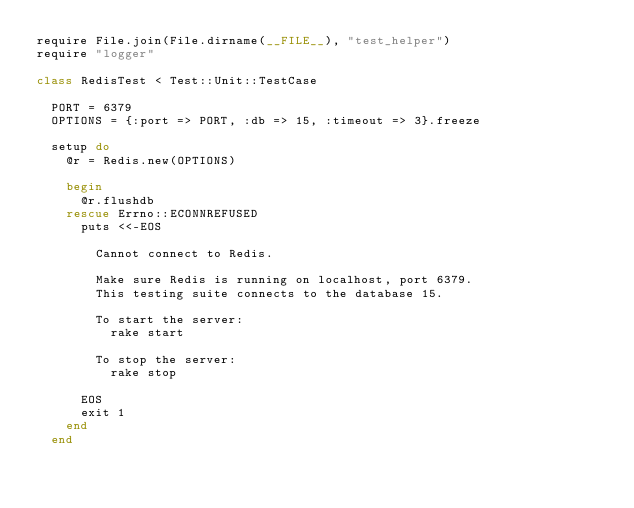<code> <loc_0><loc_0><loc_500><loc_500><_Ruby_>require File.join(File.dirname(__FILE__), "test_helper")
require "logger"

class RedisTest < Test::Unit::TestCase

  PORT = 6379
  OPTIONS = {:port => PORT, :db => 15, :timeout => 3}.freeze

  setup do
    @r = Redis.new(OPTIONS)

    begin
      @r.flushdb
    rescue Errno::ECONNREFUSED
      puts <<-EOS

        Cannot connect to Redis.

        Make sure Redis is running on localhost, port 6379.
        This testing suite connects to the database 15.

        To start the server:
          rake start

        To stop the server:
          rake stop

      EOS
      exit 1
    end
  end
</code> 